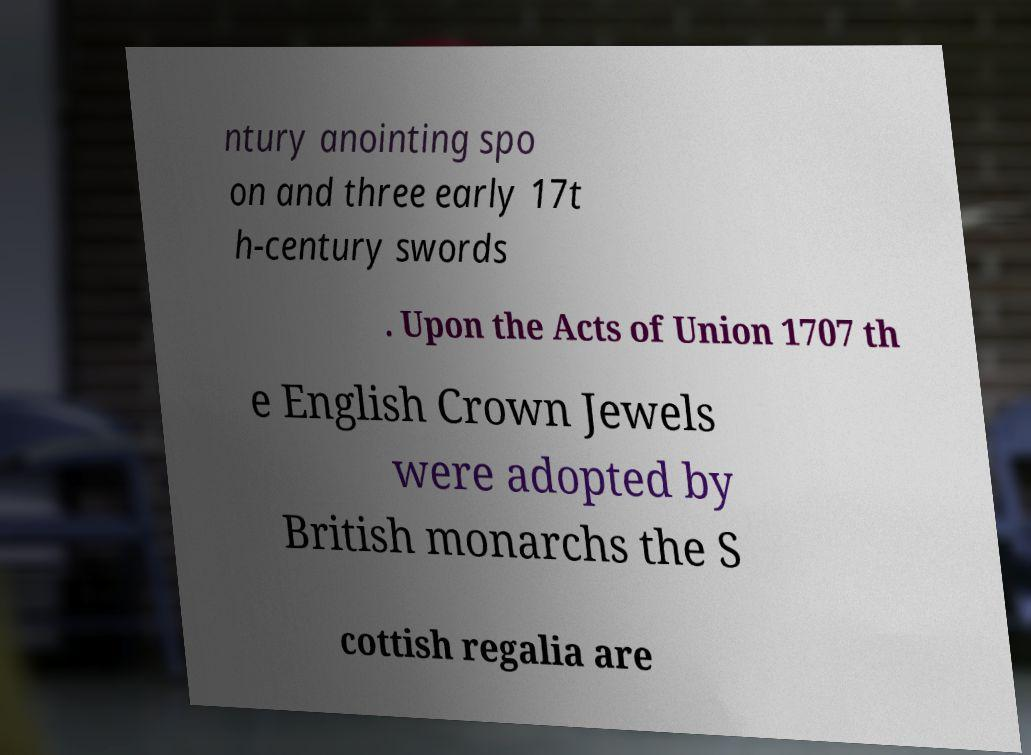Could you extract and type out the text from this image? ntury anointing spo on and three early 17t h-century swords . Upon the Acts of Union 1707 th e English Crown Jewels were adopted by British monarchs the S cottish regalia are 